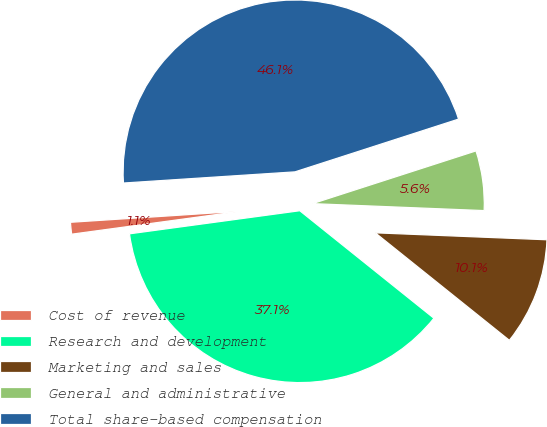Convert chart. <chart><loc_0><loc_0><loc_500><loc_500><pie_chart><fcel>Cost of revenue<fcel>Research and development<fcel>Marketing and sales<fcel>General and administrative<fcel>Total share-based compensation<nl><fcel>1.11%<fcel>37.1%<fcel>10.11%<fcel>5.61%<fcel>46.07%<nl></chart> 